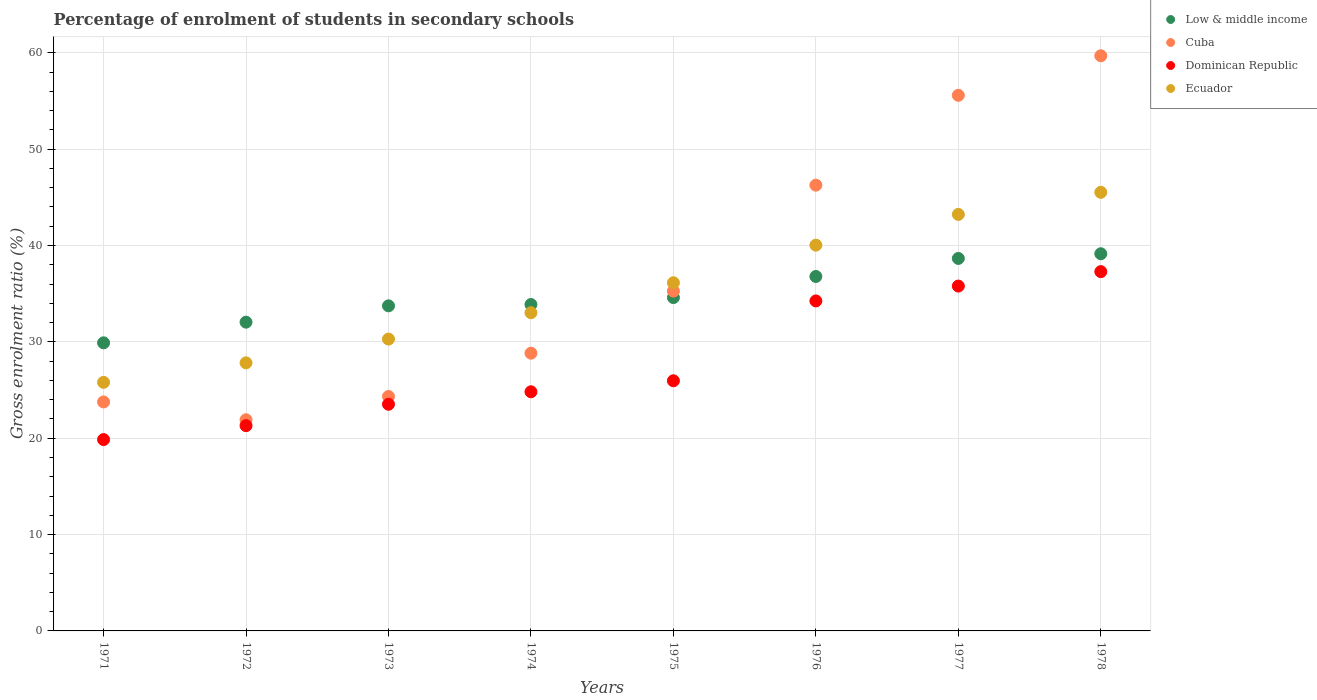How many different coloured dotlines are there?
Give a very brief answer. 4. Is the number of dotlines equal to the number of legend labels?
Ensure brevity in your answer.  Yes. What is the percentage of students enrolled in secondary schools in Cuba in 1977?
Give a very brief answer. 55.59. Across all years, what is the maximum percentage of students enrolled in secondary schools in Low & middle income?
Offer a terse response. 39.15. Across all years, what is the minimum percentage of students enrolled in secondary schools in Low & middle income?
Provide a short and direct response. 29.9. In which year was the percentage of students enrolled in secondary schools in Dominican Republic maximum?
Offer a very short reply. 1978. What is the total percentage of students enrolled in secondary schools in Ecuador in the graph?
Your answer should be compact. 281.85. What is the difference between the percentage of students enrolled in secondary schools in Ecuador in 1972 and that in 1974?
Provide a succinct answer. -5.2. What is the difference between the percentage of students enrolled in secondary schools in Low & middle income in 1971 and the percentage of students enrolled in secondary schools in Cuba in 1976?
Provide a succinct answer. -16.36. What is the average percentage of students enrolled in secondary schools in Dominican Republic per year?
Your answer should be very brief. 27.85. In the year 1974, what is the difference between the percentage of students enrolled in secondary schools in Cuba and percentage of students enrolled in secondary schools in Dominican Republic?
Provide a short and direct response. 4.01. In how many years, is the percentage of students enrolled in secondary schools in Dominican Republic greater than 40 %?
Provide a short and direct response. 0. What is the ratio of the percentage of students enrolled in secondary schools in Cuba in 1973 to that in 1974?
Your response must be concise. 0.84. Is the percentage of students enrolled in secondary schools in Dominican Republic in 1972 less than that in 1976?
Make the answer very short. Yes. What is the difference between the highest and the second highest percentage of students enrolled in secondary schools in Cuba?
Make the answer very short. 4.1. What is the difference between the highest and the lowest percentage of students enrolled in secondary schools in Cuba?
Offer a terse response. 37.78. Is the sum of the percentage of students enrolled in secondary schools in Dominican Republic in 1973 and 1976 greater than the maximum percentage of students enrolled in secondary schools in Ecuador across all years?
Provide a short and direct response. Yes. Does the percentage of students enrolled in secondary schools in Low & middle income monotonically increase over the years?
Offer a very short reply. Yes. Is the percentage of students enrolled in secondary schools in Dominican Republic strictly less than the percentage of students enrolled in secondary schools in Ecuador over the years?
Keep it short and to the point. Yes. How many years are there in the graph?
Your answer should be very brief. 8. Are the values on the major ticks of Y-axis written in scientific E-notation?
Your answer should be very brief. No. Does the graph contain any zero values?
Your response must be concise. No. Where does the legend appear in the graph?
Provide a short and direct response. Top right. How are the legend labels stacked?
Your answer should be compact. Vertical. What is the title of the graph?
Make the answer very short. Percentage of enrolment of students in secondary schools. Does "Lao PDR" appear as one of the legend labels in the graph?
Your answer should be compact. No. What is the label or title of the X-axis?
Offer a very short reply. Years. What is the Gross enrolment ratio (%) in Low & middle income in 1971?
Your answer should be compact. 29.9. What is the Gross enrolment ratio (%) in Cuba in 1971?
Keep it short and to the point. 23.76. What is the Gross enrolment ratio (%) in Dominican Republic in 1971?
Ensure brevity in your answer.  19.86. What is the Gross enrolment ratio (%) of Ecuador in 1971?
Provide a succinct answer. 25.8. What is the Gross enrolment ratio (%) of Low & middle income in 1972?
Provide a succinct answer. 32.04. What is the Gross enrolment ratio (%) of Cuba in 1972?
Your answer should be compact. 21.92. What is the Gross enrolment ratio (%) of Dominican Republic in 1972?
Your answer should be compact. 21.3. What is the Gross enrolment ratio (%) in Ecuador in 1972?
Provide a succinct answer. 27.82. What is the Gross enrolment ratio (%) in Low & middle income in 1973?
Offer a very short reply. 33.74. What is the Gross enrolment ratio (%) in Cuba in 1973?
Keep it short and to the point. 24.33. What is the Gross enrolment ratio (%) of Dominican Republic in 1973?
Keep it short and to the point. 23.52. What is the Gross enrolment ratio (%) of Ecuador in 1973?
Keep it short and to the point. 30.29. What is the Gross enrolment ratio (%) in Low & middle income in 1974?
Your response must be concise. 33.88. What is the Gross enrolment ratio (%) in Cuba in 1974?
Your answer should be very brief. 28.82. What is the Gross enrolment ratio (%) of Dominican Republic in 1974?
Your answer should be very brief. 24.82. What is the Gross enrolment ratio (%) of Ecuador in 1974?
Your answer should be very brief. 33.03. What is the Gross enrolment ratio (%) in Low & middle income in 1975?
Your answer should be very brief. 34.6. What is the Gross enrolment ratio (%) of Cuba in 1975?
Keep it short and to the point. 35.27. What is the Gross enrolment ratio (%) in Dominican Republic in 1975?
Give a very brief answer. 25.96. What is the Gross enrolment ratio (%) in Ecuador in 1975?
Your answer should be compact. 36.13. What is the Gross enrolment ratio (%) of Low & middle income in 1976?
Offer a terse response. 36.79. What is the Gross enrolment ratio (%) of Cuba in 1976?
Your answer should be very brief. 46.26. What is the Gross enrolment ratio (%) of Dominican Republic in 1976?
Make the answer very short. 34.25. What is the Gross enrolment ratio (%) of Ecuador in 1976?
Your response must be concise. 40.04. What is the Gross enrolment ratio (%) of Low & middle income in 1977?
Provide a short and direct response. 38.66. What is the Gross enrolment ratio (%) of Cuba in 1977?
Ensure brevity in your answer.  55.59. What is the Gross enrolment ratio (%) in Dominican Republic in 1977?
Offer a very short reply. 35.79. What is the Gross enrolment ratio (%) of Ecuador in 1977?
Offer a very short reply. 43.23. What is the Gross enrolment ratio (%) in Low & middle income in 1978?
Offer a very short reply. 39.15. What is the Gross enrolment ratio (%) in Cuba in 1978?
Provide a short and direct response. 59.69. What is the Gross enrolment ratio (%) of Dominican Republic in 1978?
Ensure brevity in your answer.  37.29. What is the Gross enrolment ratio (%) of Ecuador in 1978?
Offer a terse response. 45.52. Across all years, what is the maximum Gross enrolment ratio (%) of Low & middle income?
Your response must be concise. 39.15. Across all years, what is the maximum Gross enrolment ratio (%) in Cuba?
Your response must be concise. 59.69. Across all years, what is the maximum Gross enrolment ratio (%) of Dominican Republic?
Your answer should be very brief. 37.29. Across all years, what is the maximum Gross enrolment ratio (%) in Ecuador?
Your answer should be very brief. 45.52. Across all years, what is the minimum Gross enrolment ratio (%) in Low & middle income?
Your answer should be compact. 29.9. Across all years, what is the minimum Gross enrolment ratio (%) in Cuba?
Keep it short and to the point. 21.92. Across all years, what is the minimum Gross enrolment ratio (%) in Dominican Republic?
Offer a very short reply. 19.86. Across all years, what is the minimum Gross enrolment ratio (%) of Ecuador?
Offer a terse response. 25.8. What is the total Gross enrolment ratio (%) of Low & middle income in the graph?
Ensure brevity in your answer.  278.75. What is the total Gross enrolment ratio (%) of Cuba in the graph?
Your answer should be very brief. 295.65. What is the total Gross enrolment ratio (%) in Dominican Republic in the graph?
Your answer should be compact. 222.79. What is the total Gross enrolment ratio (%) of Ecuador in the graph?
Your answer should be very brief. 281.85. What is the difference between the Gross enrolment ratio (%) of Low & middle income in 1971 and that in 1972?
Offer a very short reply. -2.15. What is the difference between the Gross enrolment ratio (%) in Cuba in 1971 and that in 1972?
Keep it short and to the point. 1.85. What is the difference between the Gross enrolment ratio (%) in Dominican Republic in 1971 and that in 1972?
Give a very brief answer. -1.45. What is the difference between the Gross enrolment ratio (%) in Ecuador in 1971 and that in 1972?
Your answer should be compact. -2.02. What is the difference between the Gross enrolment ratio (%) in Low & middle income in 1971 and that in 1973?
Offer a very short reply. -3.84. What is the difference between the Gross enrolment ratio (%) of Cuba in 1971 and that in 1973?
Keep it short and to the point. -0.57. What is the difference between the Gross enrolment ratio (%) of Dominican Republic in 1971 and that in 1973?
Provide a short and direct response. -3.67. What is the difference between the Gross enrolment ratio (%) in Ecuador in 1971 and that in 1973?
Offer a terse response. -4.49. What is the difference between the Gross enrolment ratio (%) of Low & middle income in 1971 and that in 1974?
Make the answer very short. -3.98. What is the difference between the Gross enrolment ratio (%) of Cuba in 1971 and that in 1974?
Your answer should be compact. -5.06. What is the difference between the Gross enrolment ratio (%) of Dominican Republic in 1971 and that in 1974?
Offer a very short reply. -4.96. What is the difference between the Gross enrolment ratio (%) of Ecuador in 1971 and that in 1974?
Provide a succinct answer. -7.23. What is the difference between the Gross enrolment ratio (%) in Low & middle income in 1971 and that in 1975?
Keep it short and to the point. -4.7. What is the difference between the Gross enrolment ratio (%) of Cuba in 1971 and that in 1975?
Your answer should be compact. -11.5. What is the difference between the Gross enrolment ratio (%) of Dominican Republic in 1971 and that in 1975?
Keep it short and to the point. -6.1. What is the difference between the Gross enrolment ratio (%) in Ecuador in 1971 and that in 1975?
Your answer should be compact. -10.33. What is the difference between the Gross enrolment ratio (%) of Low & middle income in 1971 and that in 1976?
Make the answer very short. -6.89. What is the difference between the Gross enrolment ratio (%) of Cuba in 1971 and that in 1976?
Your answer should be very brief. -22.5. What is the difference between the Gross enrolment ratio (%) in Dominican Republic in 1971 and that in 1976?
Give a very brief answer. -14.39. What is the difference between the Gross enrolment ratio (%) of Ecuador in 1971 and that in 1976?
Keep it short and to the point. -14.24. What is the difference between the Gross enrolment ratio (%) of Low & middle income in 1971 and that in 1977?
Your answer should be very brief. -8.76. What is the difference between the Gross enrolment ratio (%) in Cuba in 1971 and that in 1977?
Ensure brevity in your answer.  -31.83. What is the difference between the Gross enrolment ratio (%) of Dominican Republic in 1971 and that in 1977?
Provide a short and direct response. -15.93. What is the difference between the Gross enrolment ratio (%) of Ecuador in 1971 and that in 1977?
Give a very brief answer. -17.43. What is the difference between the Gross enrolment ratio (%) in Low & middle income in 1971 and that in 1978?
Make the answer very short. -9.25. What is the difference between the Gross enrolment ratio (%) in Cuba in 1971 and that in 1978?
Your answer should be very brief. -35.93. What is the difference between the Gross enrolment ratio (%) in Dominican Republic in 1971 and that in 1978?
Keep it short and to the point. -17.43. What is the difference between the Gross enrolment ratio (%) in Ecuador in 1971 and that in 1978?
Make the answer very short. -19.72. What is the difference between the Gross enrolment ratio (%) in Low & middle income in 1972 and that in 1973?
Offer a very short reply. -1.69. What is the difference between the Gross enrolment ratio (%) of Cuba in 1972 and that in 1973?
Offer a very short reply. -2.42. What is the difference between the Gross enrolment ratio (%) of Dominican Republic in 1972 and that in 1973?
Offer a terse response. -2.22. What is the difference between the Gross enrolment ratio (%) in Ecuador in 1972 and that in 1973?
Give a very brief answer. -2.47. What is the difference between the Gross enrolment ratio (%) in Low & middle income in 1972 and that in 1974?
Give a very brief answer. -1.83. What is the difference between the Gross enrolment ratio (%) of Cuba in 1972 and that in 1974?
Your response must be concise. -6.91. What is the difference between the Gross enrolment ratio (%) in Dominican Republic in 1972 and that in 1974?
Ensure brevity in your answer.  -3.51. What is the difference between the Gross enrolment ratio (%) of Ecuador in 1972 and that in 1974?
Give a very brief answer. -5.2. What is the difference between the Gross enrolment ratio (%) in Low & middle income in 1972 and that in 1975?
Ensure brevity in your answer.  -2.55. What is the difference between the Gross enrolment ratio (%) in Cuba in 1972 and that in 1975?
Your answer should be compact. -13.35. What is the difference between the Gross enrolment ratio (%) of Dominican Republic in 1972 and that in 1975?
Offer a very short reply. -4.66. What is the difference between the Gross enrolment ratio (%) in Ecuador in 1972 and that in 1975?
Your response must be concise. -8.31. What is the difference between the Gross enrolment ratio (%) of Low & middle income in 1972 and that in 1976?
Your answer should be compact. -4.74. What is the difference between the Gross enrolment ratio (%) of Cuba in 1972 and that in 1976?
Your answer should be very brief. -24.35. What is the difference between the Gross enrolment ratio (%) in Dominican Republic in 1972 and that in 1976?
Provide a succinct answer. -12.94. What is the difference between the Gross enrolment ratio (%) of Ecuador in 1972 and that in 1976?
Offer a very short reply. -12.21. What is the difference between the Gross enrolment ratio (%) of Low & middle income in 1972 and that in 1977?
Offer a very short reply. -6.61. What is the difference between the Gross enrolment ratio (%) in Cuba in 1972 and that in 1977?
Your answer should be compact. -33.67. What is the difference between the Gross enrolment ratio (%) of Dominican Republic in 1972 and that in 1977?
Keep it short and to the point. -14.49. What is the difference between the Gross enrolment ratio (%) of Ecuador in 1972 and that in 1977?
Give a very brief answer. -15.41. What is the difference between the Gross enrolment ratio (%) in Low & middle income in 1972 and that in 1978?
Your answer should be very brief. -7.1. What is the difference between the Gross enrolment ratio (%) of Cuba in 1972 and that in 1978?
Ensure brevity in your answer.  -37.78. What is the difference between the Gross enrolment ratio (%) of Dominican Republic in 1972 and that in 1978?
Provide a short and direct response. -15.98. What is the difference between the Gross enrolment ratio (%) of Ecuador in 1972 and that in 1978?
Offer a very short reply. -17.7. What is the difference between the Gross enrolment ratio (%) in Low & middle income in 1973 and that in 1974?
Offer a terse response. -0.14. What is the difference between the Gross enrolment ratio (%) in Cuba in 1973 and that in 1974?
Offer a very short reply. -4.49. What is the difference between the Gross enrolment ratio (%) of Dominican Republic in 1973 and that in 1974?
Make the answer very short. -1.3. What is the difference between the Gross enrolment ratio (%) of Ecuador in 1973 and that in 1974?
Ensure brevity in your answer.  -2.74. What is the difference between the Gross enrolment ratio (%) in Low & middle income in 1973 and that in 1975?
Make the answer very short. -0.86. What is the difference between the Gross enrolment ratio (%) of Cuba in 1973 and that in 1975?
Your answer should be very brief. -10.94. What is the difference between the Gross enrolment ratio (%) of Dominican Republic in 1973 and that in 1975?
Provide a succinct answer. -2.44. What is the difference between the Gross enrolment ratio (%) in Ecuador in 1973 and that in 1975?
Your answer should be compact. -5.84. What is the difference between the Gross enrolment ratio (%) in Low & middle income in 1973 and that in 1976?
Your answer should be compact. -3.05. What is the difference between the Gross enrolment ratio (%) of Cuba in 1973 and that in 1976?
Ensure brevity in your answer.  -21.93. What is the difference between the Gross enrolment ratio (%) in Dominican Republic in 1973 and that in 1976?
Give a very brief answer. -10.73. What is the difference between the Gross enrolment ratio (%) of Ecuador in 1973 and that in 1976?
Give a very brief answer. -9.75. What is the difference between the Gross enrolment ratio (%) of Low & middle income in 1973 and that in 1977?
Keep it short and to the point. -4.92. What is the difference between the Gross enrolment ratio (%) in Cuba in 1973 and that in 1977?
Give a very brief answer. -31.26. What is the difference between the Gross enrolment ratio (%) of Dominican Republic in 1973 and that in 1977?
Offer a terse response. -12.27. What is the difference between the Gross enrolment ratio (%) in Ecuador in 1973 and that in 1977?
Offer a very short reply. -12.94. What is the difference between the Gross enrolment ratio (%) of Low & middle income in 1973 and that in 1978?
Offer a very short reply. -5.41. What is the difference between the Gross enrolment ratio (%) in Cuba in 1973 and that in 1978?
Your answer should be very brief. -35.36. What is the difference between the Gross enrolment ratio (%) in Dominican Republic in 1973 and that in 1978?
Keep it short and to the point. -13.77. What is the difference between the Gross enrolment ratio (%) of Ecuador in 1973 and that in 1978?
Ensure brevity in your answer.  -15.23. What is the difference between the Gross enrolment ratio (%) in Low & middle income in 1974 and that in 1975?
Offer a terse response. -0.72. What is the difference between the Gross enrolment ratio (%) of Cuba in 1974 and that in 1975?
Provide a succinct answer. -6.44. What is the difference between the Gross enrolment ratio (%) of Dominican Republic in 1974 and that in 1975?
Your answer should be compact. -1.14. What is the difference between the Gross enrolment ratio (%) of Ecuador in 1974 and that in 1975?
Keep it short and to the point. -3.11. What is the difference between the Gross enrolment ratio (%) in Low & middle income in 1974 and that in 1976?
Give a very brief answer. -2.91. What is the difference between the Gross enrolment ratio (%) of Cuba in 1974 and that in 1976?
Your answer should be very brief. -17.44. What is the difference between the Gross enrolment ratio (%) of Dominican Republic in 1974 and that in 1976?
Your response must be concise. -9.43. What is the difference between the Gross enrolment ratio (%) of Ecuador in 1974 and that in 1976?
Your response must be concise. -7.01. What is the difference between the Gross enrolment ratio (%) in Low & middle income in 1974 and that in 1977?
Provide a succinct answer. -4.78. What is the difference between the Gross enrolment ratio (%) in Cuba in 1974 and that in 1977?
Your response must be concise. -26.76. What is the difference between the Gross enrolment ratio (%) in Dominican Republic in 1974 and that in 1977?
Keep it short and to the point. -10.97. What is the difference between the Gross enrolment ratio (%) of Ecuador in 1974 and that in 1977?
Make the answer very short. -10.2. What is the difference between the Gross enrolment ratio (%) of Low & middle income in 1974 and that in 1978?
Offer a very short reply. -5.27. What is the difference between the Gross enrolment ratio (%) of Cuba in 1974 and that in 1978?
Offer a terse response. -30.87. What is the difference between the Gross enrolment ratio (%) in Dominican Republic in 1974 and that in 1978?
Offer a very short reply. -12.47. What is the difference between the Gross enrolment ratio (%) of Ecuador in 1974 and that in 1978?
Provide a succinct answer. -12.49. What is the difference between the Gross enrolment ratio (%) in Low & middle income in 1975 and that in 1976?
Give a very brief answer. -2.19. What is the difference between the Gross enrolment ratio (%) of Cuba in 1975 and that in 1976?
Provide a succinct answer. -11. What is the difference between the Gross enrolment ratio (%) in Dominican Republic in 1975 and that in 1976?
Your answer should be compact. -8.29. What is the difference between the Gross enrolment ratio (%) in Ecuador in 1975 and that in 1976?
Your response must be concise. -3.9. What is the difference between the Gross enrolment ratio (%) of Low & middle income in 1975 and that in 1977?
Your answer should be very brief. -4.06. What is the difference between the Gross enrolment ratio (%) in Cuba in 1975 and that in 1977?
Your response must be concise. -20.32. What is the difference between the Gross enrolment ratio (%) of Dominican Republic in 1975 and that in 1977?
Make the answer very short. -9.83. What is the difference between the Gross enrolment ratio (%) of Ecuador in 1975 and that in 1977?
Ensure brevity in your answer.  -7.09. What is the difference between the Gross enrolment ratio (%) in Low & middle income in 1975 and that in 1978?
Give a very brief answer. -4.55. What is the difference between the Gross enrolment ratio (%) of Cuba in 1975 and that in 1978?
Offer a very short reply. -24.43. What is the difference between the Gross enrolment ratio (%) in Dominican Republic in 1975 and that in 1978?
Provide a succinct answer. -11.33. What is the difference between the Gross enrolment ratio (%) in Ecuador in 1975 and that in 1978?
Offer a very short reply. -9.39. What is the difference between the Gross enrolment ratio (%) in Low & middle income in 1976 and that in 1977?
Ensure brevity in your answer.  -1.87. What is the difference between the Gross enrolment ratio (%) in Cuba in 1976 and that in 1977?
Make the answer very short. -9.32. What is the difference between the Gross enrolment ratio (%) in Dominican Republic in 1976 and that in 1977?
Your answer should be very brief. -1.54. What is the difference between the Gross enrolment ratio (%) in Ecuador in 1976 and that in 1977?
Ensure brevity in your answer.  -3.19. What is the difference between the Gross enrolment ratio (%) of Low & middle income in 1976 and that in 1978?
Ensure brevity in your answer.  -2.36. What is the difference between the Gross enrolment ratio (%) in Cuba in 1976 and that in 1978?
Give a very brief answer. -13.43. What is the difference between the Gross enrolment ratio (%) of Dominican Republic in 1976 and that in 1978?
Keep it short and to the point. -3.04. What is the difference between the Gross enrolment ratio (%) in Ecuador in 1976 and that in 1978?
Offer a terse response. -5.48. What is the difference between the Gross enrolment ratio (%) in Low & middle income in 1977 and that in 1978?
Provide a short and direct response. -0.49. What is the difference between the Gross enrolment ratio (%) in Cuba in 1977 and that in 1978?
Give a very brief answer. -4.1. What is the difference between the Gross enrolment ratio (%) in Dominican Republic in 1977 and that in 1978?
Ensure brevity in your answer.  -1.5. What is the difference between the Gross enrolment ratio (%) in Ecuador in 1977 and that in 1978?
Give a very brief answer. -2.29. What is the difference between the Gross enrolment ratio (%) of Low & middle income in 1971 and the Gross enrolment ratio (%) of Cuba in 1972?
Provide a succinct answer. 7.98. What is the difference between the Gross enrolment ratio (%) of Low & middle income in 1971 and the Gross enrolment ratio (%) of Dominican Republic in 1972?
Your answer should be compact. 8.59. What is the difference between the Gross enrolment ratio (%) of Low & middle income in 1971 and the Gross enrolment ratio (%) of Ecuador in 1972?
Give a very brief answer. 2.08. What is the difference between the Gross enrolment ratio (%) of Cuba in 1971 and the Gross enrolment ratio (%) of Dominican Republic in 1972?
Keep it short and to the point. 2.46. What is the difference between the Gross enrolment ratio (%) in Cuba in 1971 and the Gross enrolment ratio (%) in Ecuador in 1972?
Your answer should be compact. -4.06. What is the difference between the Gross enrolment ratio (%) of Dominican Republic in 1971 and the Gross enrolment ratio (%) of Ecuador in 1972?
Provide a succinct answer. -7.96. What is the difference between the Gross enrolment ratio (%) in Low & middle income in 1971 and the Gross enrolment ratio (%) in Cuba in 1973?
Provide a succinct answer. 5.57. What is the difference between the Gross enrolment ratio (%) in Low & middle income in 1971 and the Gross enrolment ratio (%) in Dominican Republic in 1973?
Make the answer very short. 6.38. What is the difference between the Gross enrolment ratio (%) of Low & middle income in 1971 and the Gross enrolment ratio (%) of Ecuador in 1973?
Offer a very short reply. -0.39. What is the difference between the Gross enrolment ratio (%) in Cuba in 1971 and the Gross enrolment ratio (%) in Dominican Republic in 1973?
Your answer should be very brief. 0.24. What is the difference between the Gross enrolment ratio (%) in Cuba in 1971 and the Gross enrolment ratio (%) in Ecuador in 1973?
Offer a very short reply. -6.53. What is the difference between the Gross enrolment ratio (%) in Dominican Republic in 1971 and the Gross enrolment ratio (%) in Ecuador in 1973?
Your answer should be very brief. -10.43. What is the difference between the Gross enrolment ratio (%) in Low & middle income in 1971 and the Gross enrolment ratio (%) in Cuba in 1974?
Your response must be concise. 1.07. What is the difference between the Gross enrolment ratio (%) in Low & middle income in 1971 and the Gross enrolment ratio (%) in Dominican Republic in 1974?
Keep it short and to the point. 5.08. What is the difference between the Gross enrolment ratio (%) in Low & middle income in 1971 and the Gross enrolment ratio (%) in Ecuador in 1974?
Your answer should be very brief. -3.13. What is the difference between the Gross enrolment ratio (%) in Cuba in 1971 and the Gross enrolment ratio (%) in Dominican Republic in 1974?
Offer a very short reply. -1.06. What is the difference between the Gross enrolment ratio (%) in Cuba in 1971 and the Gross enrolment ratio (%) in Ecuador in 1974?
Provide a succinct answer. -9.26. What is the difference between the Gross enrolment ratio (%) in Dominican Republic in 1971 and the Gross enrolment ratio (%) in Ecuador in 1974?
Provide a short and direct response. -13.17. What is the difference between the Gross enrolment ratio (%) of Low & middle income in 1971 and the Gross enrolment ratio (%) of Cuba in 1975?
Make the answer very short. -5.37. What is the difference between the Gross enrolment ratio (%) of Low & middle income in 1971 and the Gross enrolment ratio (%) of Dominican Republic in 1975?
Keep it short and to the point. 3.94. What is the difference between the Gross enrolment ratio (%) in Low & middle income in 1971 and the Gross enrolment ratio (%) in Ecuador in 1975?
Offer a very short reply. -6.23. What is the difference between the Gross enrolment ratio (%) of Cuba in 1971 and the Gross enrolment ratio (%) of Dominican Republic in 1975?
Keep it short and to the point. -2.2. What is the difference between the Gross enrolment ratio (%) of Cuba in 1971 and the Gross enrolment ratio (%) of Ecuador in 1975?
Keep it short and to the point. -12.37. What is the difference between the Gross enrolment ratio (%) in Dominican Republic in 1971 and the Gross enrolment ratio (%) in Ecuador in 1975?
Offer a terse response. -16.28. What is the difference between the Gross enrolment ratio (%) of Low & middle income in 1971 and the Gross enrolment ratio (%) of Cuba in 1976?
Your answer should be compact. -16.36. What is the difference between the Gross enrolment ratio (%) in Low & middle income in 1971 and the Gross enrolment ratio (%) in Dominican Republic in 1976?
Ensure brevity in your answer.  -4.35. What is the difference between the Gross enrolment ratio (%) of Low & middle income in 1971 and the Gross enrolment ratio (%) of Ecuador in 1976?
Keep it short and to the point. -10.14. What is the difference between the Gross enrolment ratio (%) in Cuba in 1971 and the Gross enrolment ratio (%) in Dominican Republic in 1976?
Keep it short and to the point. -10.48. What is the difference between the Gross enrolment ratio (%) of Cuba in 1971 and the Gross enrolment ratio (%) of Ecuador in 1976?
Your answer should be compact. -16.27. What is the difference between the Gross enrolment ratio (%) of Dominican Republic in 1971 and the Gross enrolment ratio (%) of Ecuador in 1976?
Your answer should be compact. -20.18. What is the difference between the Gross enrolment ratio (%) in Low & middle income in 1971 and the Gross enrolment ratio (%) in Cuba in 1977?
Offer a very short reply. -25.69. What is the difference between the Gross enrolment ratio (%) of Low & middle income in 1971 and the Gross enrolment ratio (%) of Dominican Republic in 1977?
Keep it short and to the point. -5.89. What is the difference between the Gross enrolment ratio (%) of Low & middle income in 1971 and the Gross enrolment ratio (%) of Ecuador in 1977?
Offer a terse response. -13.33. What is the difference between the Gross enrolment ratio (%) in Cuba in 1971 and the Gross enrolment ratio (%) in Dominican Republic in 1977?
Offer a very short reply. -12.03. What is the difference between the Gross enrolment ratio (%) in Cuba in 1971 and the Gross enrolment ratio (%) in Ecuador in 1977?
Your answer should be very brief. -19.46. What is the difference between the Gross enrolment ratio (%) of Dominican Republic in 1971 and the Gross enrolment ratio (%) of Ecuador in 1977?
Offer a very short reply. -23.37. What is the difference between the Gross enrolment ratio (%) of Low & middle income in 1971 and the Gross enrolment ratio (%) of Cuba in 1978?
Give a very brief answer. -29.79. What is the difference between the Gross enrolment ratio (%) in Low & middle income in 1971 and the Gross enrolment ratio (%) in Dominican Republic in 1978?
Keep it short and to the point. -7.39. What is the difference between the Gross enrolment ratio (%) in Low & middle income in 1971 and the Gross enrolment ratio (%) in Ecuador in 1978?
Your answer should be compact. -15.62. What is the difference between the Gross enrolment ratio (%) in Cuba in 1971 and the Gross enrolment ratio (%) in Dominican Republic in 1978?
Provide a short and direct response. -13.52. What is the difference between the Gross enrolment ratio (%) in Cuba in 1971 and the Gross enrolment ratio (%) in Ecuador in 1978?
Make the answer very short. -21.76. What is the difference between the Gross enrolment ratio (%) of Dominican Republic in 1971 and the Gross enrolment ratio (%) of Ecuador in 1978?
Provide a short and direct response. -25.66. What is the difference between the Gross enrolment ratio (%) of Low & middle income in 1972 and the Gross enrolment ratio (%) of Cuba in 1973?
Provide a short and direct response. 7.71. What is the difference between the Gross enrolment ratio (%) of Low & middle income in 1972 and the Gross enrolment ratio (%) of Dominican Republic in 1973?
Your response must be concise. 8.52. What is the difference between the Gross enrolment ratio (%) in Low & middle income in 1972 and the Gross enrolment ratio (%) in Ecuador in 1973?
Keep it short and to the point. 1.76. What is the difference between the Gross enrolment ratio (%) in Cuba in 1972 and the Gross enrolment ratio (%) in Dominican Republic in 1973?
Make the answer very short. -1.61. What is the difference between the Gross enrolment ratio (%) of Cuba in 1972 and the Gross enrolment ratio (%) of Ecuador in 1973?
Offer a terse response. -8.37. What is the difference between the Gross enrolment ratio (%) of Dominican Republic in 1972 and the Gross enrolment ratio (%) of Ecuador in 1973?
Give a very brief answer. -8.98. What is the difference between the Gross enrolment ratio (%) in Low & middle income in 1972 and the Gross enrolment ratio (%) in Cuba in 1974?
Make the answer very short. 3.22. What is the difference between the Gross enrolment ratio (%) in Low & middle income in 1972 and the Gross enrolment ratio (%) in Dominican Republic in 1974?
Your response must be concise. 7.23. What is the difference between the Gross enrolment ratio (%) in Low & middle income in 1972 and the Gross enrolment ratio (%) in Ecuador in 1974?
Your response must be concise. -0.98. What is the difference between the Gross enrolment ratio (%) of Cuba in 1972 and the Gross enrolment ratio (%) of Dominican Republic in 1974?
Provide a short and direct response. -2.9. What is the difference between the Gross enrolment ratio (%) of Cuba in 1972 and the Gross enrolment ratio (%) of Ecuador in 1974?
Your response must be concise. -11.11. What is the difference between the Gross enrolment ratio (%) of Dominican Republic in 1972 and the Gross enrolment ratio (%) of Ecuador in 1974?
Ensure brevity in your answer.  -11.72. What is the difference between the Gross enrolment ratio (%) in Low & middle income in 1972 and the Gross enrolment ratio (%) in Cuba in 1975?
Your answer should be very brief. -3.22. What is the difference between the Gross enrolment ratio (%) in Low & middle income in 1972 and the Gross enrolment ratio (%) in Dominican Republic in 1975?
Provide a short and direct response. 6.08. What is the difference between the Gross enrolment ratio (%) in Low & middle income in 1972 and the Gross enrolment ratio (%) in Ecuador in 1975?
Ensure brevity in your answer.  -4.09. What is the difference between the Gross enrolment ratio (%) in Cuba in 1972 and the Gross enrolment ratio (%) in Dominican Republic in 1975?
Your response must be concise. -4.05. What is the difference between the Gross enrolment ratio (%) of Cuba in 1972 and the Gross enrolment ratio (%) of Ecuador in 1975?
Your answer should be compact. -14.22. What is the difference between the Gross enrolment ratio (%) of Dominican Republic in 1972 and the Gross enrolment ratio (%) of Ecuador in 1975?
Provide a succinct answer. -14.83. What is the difference between the Gross enrolment ratio (%) in Low & middle income in 1972 and the Gross enrolment ratio (%) in Cuba in 1976?
Offer a terse response. -14.22. What is the difference between the Gross enrolment ratio (%) of Low & middle income in 1972 and the Gross enrolment ratio (%) of Dominican Republic in 1976?
Ensure brevity in your answer.  -2.2. What is the difference between the Gross enrolment ratio (%) in Low & middle income in 1972 and the Gross enrolment ratio (%) in Ecuador in 1976?
Your response must be concise. -7.99. What is the difference between the Gross enrolment ratio (%) of Cuba in 1972 and the Gross enrolment ratio (%) of Dominican Republic in 1976?
Provide a short and direct response. -12.33. What is the difference between the Gross enrolment ratio (%) of Cuba in 1972 and the Gross enrolment ratio (%) of Ecuador in 1976?
Provide a succinct answer. -18.12. What is the difference between the Gross enrolment ratio (%) of Dominican Republic in 1972 and the Gross enrolment ratio (%) of Ecuador in 1976?
Your response must be concise. -18.73. What is the difference between the Gross enrolment ratio (%) in Low & middle income in 1972 and the Gross enrolment ratio (%) in Cuba in 1977?
Make the answer very short. -23.54. What is the difference between the Gross enrolment ratio (%) of Low & middle income in 1972 and the Gross enrolment ratio (%) of Dominican Republic in 1977?
Your response must be concise. -3.75. What is the difference between the Gross enrolment ratio (%) of Low & middle income in 1972 and the Gross enrolment ratio (%) of Ecuador in 1977?
Make the answer very short. -11.18. What is the difference between the Gross enrolment ratio (%) in Cuba in 1972 and the Gross enrolment ratio (%) in Dominican Republic in 1977?
Your answer should be compact. -13.87. What is the difference between the Gross enrolment ratio (%) of Cuba in 1972 and the Gross enrolment ratio (%) of Ecuador in 1977?
Your answer should be very brief. -21.31. What is the difference between the Gross enrolment ratio (%) of Dominican Republic in 1972 and the Gross enrolment ratio (%) of Ecuador in 1977?
Keep it short and to the point. -21.92. What is the difference between the Gross enrolment ratio (%) of Low & middle income in 1972 and the Gross enrolment ratio (%) of Cuba in 1978?
Offer a terse response. -27.65. What is the difference between the Gross enrolment ratio (%) in Low & middle income in 1972 and the Gross enrolment ratio (%) in Dominican Republic in 1978?
Your response must be concise. -5.24. What is the difference between the Gross enrolment ratio (%) in Low & middle income in 1972 and the Gross enrolment ratio (%) in Ecuador in 1978?
Provide a succinct answer. -13.47. What is the difference between the Gross enrolment ratio (%) in Cuba in 1972 and the Gross enrolment ratio (%) in Dominican Republic in 1978?
Make the answer very short. -15.37. What is the difference between the Gross enrolment ratio (%) of Cuba in 1972 and the Gross enrolment ratio (%) of Ecuador in 1978?
Ensure brevity in your answer.  -23.6. What is the difference between the Gross enrolment ratio (%) in Dominican Republic in 1972 and the Gross enrolment ratio (%) in Ecuador in 1978?
Provide a short and direct response. -24.22. What is the difference between the Gross enrolment ratio (%) of Low & middle income in 1973 and the Gross enrolment ratio (%) of Cuba in 1974?
Your answer should be very brief. 4.91. What is the difference between the Gross enrolment ratio (%) in Low & middle income in 1973 and the Gross enrolment ratio (%) in Dominican Republic in 1974?
Make the answer very short. 8.92. What is the difference between the Gross enrolment ratio (%) of Low & middle income in 1973 and the Gross enrolment ratio (%) of Ecuador in 1974?
Offer a terse response. 0.71. What is the difference between the Gross enrolment ratio (%) of Cuba in 1973 and the Gross enrolment ratio (%) of Dominican Republic in 1974?
Your answer should be very brief. -0.49. What is the difference between the Gross enrolment ratio (%) of Cuba in 1973 and the Gross enrolment ratio (%) of Ecuador in 1974?
Your answer should be very brief. -8.69. What is the difference between the Gross enrolment ratio (%) in Dominican Republic in 1973 and the Gross enrolment ratio (%) in Ecuador in 1974?
Offer a very short reply. -9.5. What is the difference between the Gross enrolment ratio (%) of Low & middle income in 1973 and the Gross enrolment ratio (%) of Cuba in 1975?
Make the answer very short. -1.53. What is the difference between the Gross enrolment ratio (%) of Low & middle income in 1973 and the Gross enrolment ratio (%) of Dominican Republic in 1975?
Give a very brief answer. 7.78. What is the difference between the Gross enrolment ratio (%) of Low & middle income in 1973 and the Gross enrolment ratio (%) of Ecuador in 1975?
Keep it short and to the point. -2.39. What is the difference between the Gross enrolment ratio (%) in Cuba in 1973 and the Gross enrolment ratio (%) in Dominican Republic in 1975?
Your answer should be very brief. -1.63. What is the difference between the Gross enrolment ratio (%) of Cuba in 1973 and the Gross enrolment ratio (%) of Ecuador in 1975?
Provide a succinct answer. -11.8. What is the difference between the Gross enrolment ratio (%) of Dominican Republic in 1973 and the Gross enrolment ratio (%) of Ecuador in 1975?
Provide a succinct answer. -12.61. What is the difference between the Gross enrolment ratio (%) in Low & middle income in 1973 and the Gross enrolment ratio (%) in Cuba in 1976?
Make the answer very short. -12.53. What is the difference between the Gross enrolment ratio (%) of Low & middle income in 1973 and the Gross enrolment ratio (%) of Dominican Republic in 1976?
Your response must be concise. -0.51. What is the difference between the Gross enrolment ratio (%) in Low & middle income in 1973 and the Gross enrolment ratio (%) in Ecuador in 1976?
Ensure brevity in your answer.  -6.3. What is the difference between the Gross enrolment ratio (%) of Cuba in 1973 and the Gross enrolment ratio (%) of Dominican Republic in 1976?
Give a very brief answer. -9.92. What is the difference between the Gross enrolment ratio (%) of Cuba in 1973 and the Gross enrolment ratio (%) of Ecuador in 1976?
Your response must be concise. -15.71. What is the difference between the Gross enrolment ratio (%) in Dominican Republic in 1973 and the Gross enrolment ratio (%) in Ecuador in 1976?
Your answer should be compact. -16.51. What is the difference between the Gross enrolment ratio (%) of Low & middle income in 1973 and the Gross enrolment ratio (%) of Cuba in 1977?
Your response must be concise. -21.85. What is the difference between the Gross enrolment ratio (%) of Low & middle income in 1973 and the Gross enrolment ratio (%) of Dominican Republic in 1977?
Your response must be concise. -2.05. What is the difference between the Gross enrolment ratio (%) in Low & middle income in 1973 and the Gross enrolment ratio (%) in Ecuador in 1977?
Give a very brief answer. -9.49. What is the difference between the Gross enrolment ratio (%) of Cuba in 1973 and the Gross enrolment ratio (%) of Dominican Republic in 1977?
Give a very brief answer. -11.46. What is the difference between the Gross enrolment ratio (%) of Cuba in 1973 and the Gross enrolment ratio (%) of Ecuador in 1977?
Keep it short and to the point. -18.9. What is the difference between the Gross enrolment ratio (%) of Dominican Republic in 1973 and the Gross enrolment ratio (%) of Ecuador in 1977?
Keep it short and to the point. -19.7. What is the difference between the Gross enrolment ratio (%) in Low & middle income in 1973 and the Gross enrolment ratio (%) in Cuba in 1978?
Make the answer very short. -25.95. What is the difference between the Gross enrolment ratio (%) of Low & middle income in 1973 and the Gross enrolment ratio (%) of Dominican Republic in 1978?
Give a very brief answer. -3.55. What is the difference between the Gross enrolment ratio (%) in Low & middle income in 1973 and the Gross enrolment ratio (%) in Ecuador in 1978?
Your answer should be very brief. -11.78. What is the difference between the Gross enrolment ratio (%) in Cuba in 1973 and the Gross enrolment ratio (%) in Dominican Republic in 1978?
Ensure brevity in your answer.  -12.96. What is the difference between the Gross enrolment ratio (%) in Cuba in 1973 and the Gross enrolment ratio (%) in Ecuador in 1978?
Your answer should be very brief. -21.19. What is the difference between the Gross enrolment ratio (%) in Dominican Republic in 1973 and the Gross enrolment ratio (%) in Ecuador in 1978?
Offer a terse response. -22. What is the difference between the Gross enrolment ratio (%) in Low & middle income in 1974 and the Gross enrolment ratio (%) in Cuba in 1975?
Offer a very short reply. -1.39. What is the difference between the Gross enrolment ratio (%) in Low & middle income in 1974 and the Gross enrolment ratio (%) in Dominican Republic in 1975?
Provide a succinct answer. 7.91. What is the difference between the Gross enrolment ratio (%) of Low & middle income in 1974 and the Gross enrolment ratio (%) of Ecuador in 1975?
Keep it short and to the point. -2.26. What is the difference between the Gross enrolment ratio (%) of Cuba in 1974 and the Gross enrolment ratio (%) of Dominican Republic in 1975?
Make the answer very short. 2.86. What is the difference between the Gross enrolment ratio (%) of Cuba in 1974 and the Gross enrolment ratio (%) of Ecuador in 1975?
Make the answer very short. -7.31. What is the difference between the Gross enrolment ratio (%) of Dominican Republic in 1974 and the Gross enrolment ratio (%) of Ecuador in 1975?
Keep it short and to the point. -11.31. What is the difference between the Gross enrolment ratio (%) of Low & middle income in 1974 and the Gross enrolment ratio (%) of Cuba in 1976?
Your answer should be compact. -12.39. What is the difference between the Gross enrolment ratio (%) in Low & middle income in 1974 and the Gross enrolment ratio (%) in Dominican Republic in 1976?
Your answer should be compact. -0.37. What is the difference between the Gross enrolment ratio (%) in Low & middle income in 1974 and the Gross enrolment ratio (%) in Ecuador in 1976?
Provide a short and direct response. -6.16. What is the difference between the Gross enrolment ratio (%) in Cuba in 1974 and the Gross enrolment ratio (%) in Dominican Republic in 1976?
Offer a terse response. -5.42. What is the difference between the Gross enrolment ratio (%) of Cuba in 1974 and the Gross enrolment ratio (%) of Ecuador in 1976?
Give a very brief answer. -11.21. What is the difference between the Gross enrolment ratio (%) of Dominican Republic in 1974 and the Gross enrolment ratio (%) of Ecuador in 1976?
Your response must be concise. -15.22. What is the difference between the Gross enrolment ratio (%) of Low & middle income in 1974 and the Gross enrolment ratio (%) of Cuba in 1977?
Your answer should be compact. -21.71. What is the difference between the Gross enrolment ratio (%) in Low & middle income in 1974 and the Gross enrolment ratio (%) in Dominican Republic in 1977?
Keep it short and to the point. -1.91. What is the difference between the Gross enrolment ratio (%) of Low & middle income in 1974 and the Gross enrolment ratio (%) of Ecuador in 1977?
Offer a very short reply. -9.35. What is the difference between the Gross enrolment ratio (%) in Cuba in 1974 and the Gross enrolment ratio (%) in Dominican Republic in 1977?
Provide a succinct answer. -6.97. What is the difference between the Gross enrolment ratio (%) in Cuba in 1974 and the Gross enrolment ratio (%) in Ecuador in 1977?
Your answer should be very brief. -14.4. What is the difference between the Gross enrolment ratio (%) of Dominican Republic in 1974 and the Gross enrolment ratio (%) of Ecuador in 1977?
Ensure brevity in your answer.  -18.41. What is the difference between the Gross enrolment ratio (%) of Low & middle income in 1974 and the Gross enrolment ratio (%) of Cuba in 1978?
Provide a short and direct response. -25.82. What is the difference between the Gross enrolment ratio (%) in Low & middle income in 1974 and the Gross enrolment ratio (%) in Dominican Republic in 1978?
Your answer should be compact. -3.41. What is the difference between the Gross enrolment ratio (%) in Low & middle income in 1974 and the Gross enrolment ratio (%) in Ecuador in 1978?
Ensure brevity in your answer.  -11.64. What is the difference between the Gross enrolment ratio (%) in Cuba in 1974 and the Gross enrolment ratio (%) in Dominican Republic in 1978?
Ensure brevity in your answer.  -8.46. What is the difference between the Gross enrolment ratio (%) of Cuba in 1974 and the Gross enrolment ratio (%) of Ecuador in 1978?
Ensure brevity in your answer.  -16.7. What is the difference between the Gross enrolment ratio (%) of Dominican Republic in 1974 and the Gross enrolment ratio (%) of Ecuador in 1978?
Provide a short and direct response. -20.7. What is the difference between the Gross enrolment ratio (%) of Low & middle income in 1975 and the Gross enrolment ratio (%) of Cuba in 1976?
Provide a short and direct response. -11.67. What is the difference between the Gross enrolment ratio (%) in Low & middle income in 1975 and the Gross enrolment ratio (%) in Dominican Republic in 1976?
Your answer should be compact. 0.35. What is the difference between the Gross enrolment ratio (%) of Low & middle income in 1975 and the Gross enrolment ratio (%) of Ecuador in 1976?
Ensure brevity in your answer.  -5.44. What is the difference between the Gross enrolment ratio (%) in Cuba in 1975 and the Gross enrolment ratio (%) in Dominican Republic in 1976?
Give a very brief answer. 1.02. What is the difference between the Gross enrolment ratio (%) of Cuba in 1975 and the Gross enrolment ratio (%) of Ecuador in 1976?
Keep it short and to the point. -4.77. What is the difference between the Gross enrolment ratio (%) in Dominican Republic in 1975 and the Gross enrolment ratio (%) in Ecuador in 1976?
Offer a very short reply. -14.08. What is the difference between the Gross enrolment ratio (%) of Low & middle income in 1975 and the Gross enrolment ratio (%) of Cuba in 1977?
Your response must be concise. -20.99. What is the difference between the Gross enrolment ratio (%) in Low & middle income in 1975 and the Gross enrolment ratio (%) in Dominican Republic in 1977?
Offer a very short reply. -1.19. What is the difference between the Gross enrolment ratio (%) in Low & middle income in 1975 and the Gross enrolment ratio (%) in Ecuador in 1977?
Provide a succinct answer. -8.63. What is the difference between the Gross enrolment ratio (%) of Cuba in 1975 and the Gross enrolment ratio (%) of Dominican Republic in 1977?
Offer a terse response. -0.52. What is the difference between the Gross enrolment ratio (%) of Cuba in 1975 and the Gross enrolment ratio (%) of Ecuador in 1977?
Offer a terse response. -7.96. What is the difference between the Gross enrolment ratio (%) in Dominican Republic in 1975 and the Gross enrolment ratio (%) in Ecuador in 1977?
Give a very brief answer. -17.27. What is the difference between the Gross enrolment ratio (%) of Low & middle income in 1975 and the Gross enrolment ratio (%) of Cuba in 1978?
Your answer should be compact. -25.1. What is the difference between the Gross enrolment ratio (%) in Low & middle income in 1975 and the Gross enrolment ratio (%) in Dominican Republic in 1978?
Ensure brevity in your answer.  -2.69. What is the difference between the Gross enrolment ratio (%) in Low & middle income in 1975 and the Gross enrolment ratio (%) in Ecuador in 1978?
Make the answer very short. -10.92. What is the difference between the Gross enrolment ratio (%) of Cuba in 1975 and the Gross enrolment ratio (%) of Dominican Republic in 1978?
Your answer should be compact. -2.02. What is the difference between the Gross enrolment ratio (%) in Cuba in 1975 and the Gross enrolment ratio (%) in Ecuador in 1978?
Make the answer very short. -10.25. What is the difference between the Gross enrolment ratio (%) in Dominican Republic in 1975 and the Gross enrolment ratio (%) in Ecuador in 1978?
Give a very brief answer. -19.56. What is the difference between the Gross enrolment ratio (%) in Low & middle income in 1976 and the Gross enrolment ratio (%) in Cuba in 1977?
Your answer should be very brief. -18.8. What is the difference between the Gross enrolment ratio (%) of Low & middle income in 1976 and the Gross enrolment ratio (%) of Ecuador in 1977?
Your answer should be compact. -6.44. What is the difference between the Gross enrolment ratio (%) in Cuba in 1976 and the Gross enrolment ratio (%) in Dominican Republic in 1977?
Offer a terse response. 10.47. What is the difference between the Gross enrolment ratio (%) of Cuba in 1976 and the Gross enrolment ratio (%) of Ecuador in 1977?
Your response must be concise. 3.04. What is the difference between the Gross enrolment ratio (%) in Dominican Republic in 1976 and the Gross enrolment ratio (%) in Ecuador in 1977?
Make the answer very short. -8.98. What is the difference between the Gross enrolment ratio (%) in Low & middle income in 1976 and the Gross enrolment ratio (%) in Cuba in 1978?
Provide a succinct answer. -22.91. What is the difference between the Gross enrolment ratio (%) of Low & middle income in 1976 and the Gross enrolment ratio (%) of Dominican Republic in 1978?
Make the answer very short. -0.5. What is the difference between the Gross enrolment ratio (%) in Low & middle income in 1976 and the Gross enrolment ratio (%) in Ecuador in 1978?
Provide a short and direct response. -8.73. What is the difference between the Gross enrolment ratio (%) of Cuba in 1976 and the Gross enrolment ratio (%) of Dominican Republic in 1978?
Give a very brief answer. 8.98. What is the difference between the Gross enrolment ratio (%) in Cuba in 1976 and the Gross enrolment ratio (%) in Ecuador in 1978?
Your response must be concise. 0.74. What is the difference between the Gross enrolment ratio (%) in Dominican Republic in 1976 and the Gross enrolment ratio (%) in Ecuador in 1978?
Offer a terse response. -11.27. What is the difference between the Gross enrolment ratio (%) in Low & middle income in 1977 and the Gross enrolment ratio (%) in Cuba in 1978?
Your answer should be very brief. -21.03. What is the difference between the Gross enrolment ratio (%) in Low & middle income in 1977 and the Gross enrolment ratio (%) in Dominican Republic in 1978?
Give a very brief answer. 1.37. What is the difference between the Gross enrolment ratio (%) of Low & middle income in 1977 and the Gross enrolment ratio (%) of Ecuador in 1978?
Offer a terse response. -6.86. What is the difference between the Gross enrolment ratio (%) in Cuba in 1977 and the Gross enrolment ratio (%) in Dominican Republic in 1978?
Provide a short and direct response. 18.3. What is the difference between the Gross enrolment ratio (%) of Cuba in 1977 and the Gross enrolment ratio (%) of Ecuador in 1978?
Offer a very short reply. 10.07. What is the difference between the Gross enrolment ratio (%) in Dominican Republic in 1977 and the Gross enrolment ratio (%) in Ecuador in 1978?
Offer a very short reply. -9.73. What is the average Gross enrolment ratio (%) in Low & middle income per year?
Ensure brevity in your answer.  34.84. What is the average Gross enrolment ratio (%) of Cuba per year?
Provide a short and direct response. 36.96. What is the average Gross enrolment ratio (%) in Dominican Republic per year?
Provide a short and direct response. 27.85. What is the average Gross enrolment ratio (%) in Ecuador per year?
Keep it short and to the point. 35.23. In the year 1971, what is the difference between the Gross enrolment ratio (%) of Low & middle income and Gross enrolment ratio (%) of Cuba?
Offer a terse response. 6.14. In the year 1971, what is the difference between the Gross enrolment ratio (%) of Low & middle income and Gross enrolment ratio (%) of Dominican Republic?
Make the answer very short. 10.04. In the year 1971, what is the difference between the Gross enrolment ratio (%) in Low & middle income and Gross enrolment ratio (%) in Ecuador?
Offer a very short reply. 4.1. In the year 1971, what is the difference between the Gross enrolment ratio (%) in Cuba and Gross enrolment ratio (%) in Dominican Republic?
Give a very brief answer. 3.91. In the year 1971, what is the difference between the Gross enrolment ratio (%) in Cuba and Gross enrolment ratio (%) in Ecuador?
Offer a very short reply. -2.04. In the year 1971, what is the difference between the Gross enrolment ratio (%) in Dominican Republic and Gross enrolment ratio (%) in Ecuador?
Give a very brief answer. -5.94. In the year 1972, what is the difference between the Gross enrolment ratio (%) in Low & middle income and Gross enrolment ratio (%) in Cuba?
Make the answer very short. 10.13. In the year 1972, what is the difference between the Gross enrolment ratio (%) of Low & middle income and Gross enrolment ratio (%) of Dominican Republic?
Offer a very short reply. 10.74. In the year 1972, what is the difference between the Gross enrolment ratio (%) of Low & middle income and Gross enrolment ratio (%) of Ecuador?
Offer a terse response. 4.22. In the year 1972, what is the difference between the Gross enrolment ratio (%) of Cuba and Gross enrolment ratio (%) of Dominican Republic?
Offer a very short reply. 0.61. In the year 1972, what is the difference between the Gross enrolment ratio (%) of Cuba and Gross enrolment ratio (%) of Ecuador?
Provide a short and direct response. -5.91. In the year 1972, what is the difference between the Gross enrolment ratio (%) of Dominican Republic and Gross enrolment ratio (%) of Ecuador?
Make the answer very short. -6.52. In the year 1973, what is the difference between the Gross enrolment ratio (%) of Low & middle income and Gross enrolment ratio (%) of Cuba?
Provide a short and direct response. 9.41. In the year 1973, what is the difference between the Gross enrolment ratio (%) of Low & middle income and Gross enrolment ratio (%) of Dominican Republic?
Provide a succinct answer. 10.22. In the year 1973, what is the difference between the Gross enrolment ratio (%) in Low & middle income and Gross enrolment ratio (%) in Ecuador?
Provide a short and direct response. 3.45. In the year 1973, what is the difference between the Gross enrolment ratio (%) of Cuba and Gross enrolment ratio (%) of Dominican Republic?
Provide a succinct answer. 0.81. In the year 1973, what is the difference between the Gross enrolment ratio (%) of Cuba and Gross enrolment ratio (%) of Ecuador?
Make the answer very short. -5.96. In the year 1973, what is the difference between the Gross enrolment ratio (%) of Dominican Republic and Gross enrolment ratio (%) of Ecuador?
Provide a short and direct response. -6.77. In the year 1974, what is the difference between the Gross enrolment ratio (%) in Low & middle income and Gross enrolment ratio (%) in Cuba?
Your answer should be very brief. 5.05. In the year 1974, what is the difference between the Gross enrolment ratio (%) of Low & middle income and Gross enrolment ratio (%) of Dominican Republic?
Keep it short and to the point. 9.06. In the year 1974, what is the difference between the Gross enrolment ratio (%) in Low & middle income and Gross enrolment ratio (%) in Ecuador?
Make the answer very short. 0.85. In the year 1974, what is the difference between the Gross enrolment ratio (%) in Cuba and Gross enrolment ratio (%) in Dominican Republic?
Keep it short and to the point. 4.01. In the year 1974, what is the difference between the Gross enrolment ratio (%) of Cuba and Gross enrolment ratio (%) of Ecuador?
Offer a very short reply. -4.2. In the year 1974, what is the difference between the Gross enrolment ratio (%) of Dominican Republic and Gross enrolment ratio (%) of Ecuador?
Provide a short and direct response. -8.21. In the year 1975, what is the difference between the Gross enrolment ratio (%) in Low & middle income and Gross enrolment ratio (%) in Cuba?
Make the answer very short. -0.67. In the year 1975, what is the difference between the Gross enrolment ratio (%) of Low & middle income and Gross enrolment ratio (%) of Dominican Republic?
Offer a very short reply. 8.64. In the year 1975, what is the difference between the Gross enrolment ratio (%) in Low & middle income and Gross enrolment ratio (%) in Ecuador?
Make the answer very short. -1.54. In the year 1975, what is the difference between the Gross enrolment ratio (%) in Cuba and Gross enrolment ratio (%) in Dominican Republic?
Offer a very short reply. 9.31. In the year 1975, what is the difference between the Gross enrolment ratio (%) in Cuba and Gross enrolment ratio (%) in Ecuador?
Ensure brevity in your answer.  -0.87. In the year 1975, what is the difference between the Gross enrolment ratio (%) in Dominican Republic and Gross enrolment ratio (%) in Ecuador?
Offer a very short reply. -10.17. In the year 1976, what is the difference between the Gross enrolment ratio (%) in Low & middle income and Gross enrolment ratio (%) in Cuba?
Provide a short and direct response. -9.48. In the year 1976, what is the difference between the Gross enrolment ratio (%) of Low & middle income and Gross enrolment ratio (%) of Dominican Republic?
Your answer should be compact. 2.54. In the year 1976, what is the difference between the Gross enrolment ratio (%) in Low & middle income and Gross enrolment ratio (%) in Ecuador?
Provide a short and direct response. -3.25. In the year 1976, what is the difference between the Gross enrolment ratio (%) of Cuba and Gross enrolment ratio (%) of Dominican Republic?
Offer a terse response. 12.02. In the year 1976, what is the difference between the Gross enrolment ratio (%) in Cuba and Gross enrolment ratio (%) in Ecuador?
Keep it short and to the point. 6.23. In the year 1976, what is the difference between the Gross enrolment ratio (%) in Dominican Republic and Gross enrolment ratio (%) in Ecuador?
Offer a very short reply. -5.79. In the year 1977, what is the difference between the Gross enrolment ratio (%) in Low & middle income and Gross enrolment ratio (%) in Cuba?
Provide a short and direct response. -16.93. In the year 1977, what is the difference between the Gross enrolment ratio (%) in Low & middle income and Gross enrolment ratio (%) in Dominican Republic?
Provide a short and direct response. 2.87. In the year 1977, what is the difference between the Gross enrolment ratio (%) of Low & middle income and Gross enrolment ratio (%) of Ecuador?
Give a very brief answer. -4.57. In the year 1977, what is the difference between the Gross enrolment ratio (%) of Cuba and Gross enrolment ratio (%) of Dominican Republic?
Make the answer very short. 19.8. In the year 1977, what is the difference between the Gross enrolment ratio (%) of Cuba and Gross enrolment ratio (%) of Ecuador?
Your answer should be very brief. 12.36. In the year 1977, what is the difference between the Gross enrolment ratio (%) of Dominican Republic and Gross enrolment ratio (%) of Ecuador?
Provide a short and direct response. -7.44. In the year 1978, what is the difference between the Gross enrolment ratio (%) of Low & middle income and Gross enrolment ratio (%) of Cuba?
Provide a succinct answer. -20.55. In the year 1978, what is the difference between the Gross enrolment ratio (%) in Low & middle income and Gross enrolment ratio (%) in Dominican Republic?
Your answer should be compact. 1.86. In the year 1978, what is the difference between the Gross enrolment ratio (%) in Low & middle income and Gross enrolment ratio (%) in Ecuador?
Your answer should be very brief. -6.37. In the year 1978, what is the difference between the Gross enrolment ratio (%) in Cuba and Gross enrolment ratio (%) in Dominican Republic?
Make the answer very short. 22.4. In the year 1978, what is the difference between the Gross enrolment ratio (%) in Cuba and Gross enrolment ratio (%) in Ecuador?
Make the answer very short. 14.17. In the year 1978, what is the difference between the Gross enrolment ratio (%) of Dominican Republic and Gross enrolment ratio (%) of Ecuador?
Offer a very short reply. -8.23. What is the ratio of the Gross enrolment ratio (%) in Low & middle income in 1971 to that in 1972?
Provide a succinct answer. 0.93. What is the ratio of the Gross enrolment ratio (%) of Cuba in 1971 to that in 1972?
Give a very brief answer. 1.08. What is the ratio of the Gross enrolment ratio (%) in Dominican Republic in 1971 to that in 1972?
Your answer should be very brief. 0.93. What is the ratio of the Gross enrolment ratio (%) in Ecuador in 1971 to that in 1972?
Provide a succinct answer. 0.93. What is the ratio of the Gross enrolment ratio (%) of Low & middle income in 1971 to that in 1973?
Give a very brief answer. 0.89. What is the ratio of the Gross enrolment ratio (%) in Cuba in 1971 to that in 1973?
Make the answer very short. 0.98. What is the ratio of the Gross enrolment ratio (%) of Dominican Republic in 1971 to that in 1973?
Give a very brief answer. 0.84. What is the ratio of the Gross enrolment ratio (%) in Ecuador in 1971 to that in 1973?
Provide a short and direct response. 0.85. What is the ratio of the Gross enrolment ratio (%) of Low & middle income in 1971 to that in 1974?
Your response must be concise. 0.88. What is the ratio of the Gross enrolment ratio (%) of Cuba in 1971 to that in 1974?
Your answer should be very brief. 0.82. What is the ratio of the Gross enrolment ratio (%) of Dominican Republic in 1971 to that in 1974?
Provide a succinct answer. 0.8. What is the ratio of the Gross enrolment ratio (%) of Ecuador in 1971 to that in 1974?
Your answer should be compact. 0.78. What is the ratio of the Gross enrolment ratio (%) in Low & middle income in 1971 to that in 1975?
Make the answer very short. 0.86. What is the ratio of the Gross enrolment ratio (%) in Cuba in 1971 to that in 1975?
Offer a very short reply. 0.67. What is the ratio of the Gross enrolment ratio (%) in Dominican Republic in 1971 to that in 1975?
Your response must be concise. 0.76. What is the ratio of the Gross enrolment ratio (%) of Ecuador in 1971 to that in 1975?
Give a very brief answer. 0.71. What is the ratio of the Gross enrolment ratio (%) in Low & middle income in 1971 to that in 1976?
Your response must be concise. 0.81. What is the ratio of the Gross enrolment ratio (%) of Cuba in 1971 to that in 1976?
Offer a very short reply. 0.51. What is the ratio of the Gross enrolment ratio (%) in Dominican Republic in 1971 to that in 1976?
Provide a succinct answer. 0.58. What is the ratio of the Gross enrolment ratio (%) in Ecuador in 1971 to that in 1976?
Keep it short and to the point. 0.64. What is the ratio of the Gross enrolment ratio (%) in Low & middle income in 1971 to that in 1977?
Keep it short and to the point. 0.77. What is the ratio of the Gross enrolment ratio (%) of Cuba in 1971 to that in 1977?
Your answer should be very brief. 0.43. What is the ratio of the Gross enrolment ratio (%) in Dominican Republic in 1971 to that in 1977?
Provide a succinct answer. 0.55. What is the ratio of the Gross enrolment ratio (%) in Ecuador in 1971 to that in 1977?
Provide a short and direct response. 0.6. What is the ratio of the Gross enrolment ratio (%) in Low & middle income in 1971 to that in 1978?
Give a very brief answer. 0.76. What is the ratio of the Gross enrolment ratio (%) in Cuba in 1971 to that in 1978?
Your response must be concise. 0.4. What is the ratio of the Gross enrolment ratio (%) in Dominican Republic in 1971 to that in 1978?
Offer a very short reply. 0.53. What is the ratio of the Gross enrolment ratio (%) of Ecuador in 1971 to that in 1978?
Ensure brevity in your answer.  0.57. What is the ratio of the Gross enrolment ratio (%) in Low & middle income in 1972 to that in 1973?
Your answer should be very brief. 0.95. What is the ratio of the Gross enrolment ratio (%) in Cuba in 1972 to that in 1973?
Make the answer very short. 0.9. What is the ratio of the Gross enrolment ratio (%) in Dominican Republic in 1972 to that in 1973?
Your answer should be compact. 0.91. What is the ratio of the Gross enrolment ratio (%) of Ecuador in 1972 to that in 1973?
Your answer should be very brief. 0.92. What is the ratio of the Gross enrolment ratio (%) in Low & middle income in 1972 to that in 1974?
Your answer should be very brief. 0.95. What is the ratio of the Gross enrolment ratio (%) of Cuba in 1972 to that in 1974?
Your answer should be compact. 0.76. What is the ratio of the Gross enrolment ratio (%) in Dominican Republic in 1972 to that in 1974?
Your answer should be very brief. 0.86. What is the ratio of the Gross enrolment ratio (%) of Ecuador in 1972 to that in 1974?
Offer a very short reply. 0.84. What is the ratio of the Gross enrolment ratio (%) in Low & middle income in 1972 to that in 1975?
Your response must be concise. 0.93. What is the ratio of the Gross enrolment ratio (%) of Cuba in 1972 to that in 1975?
Your response must be concise. 0.62. What is the ratio of the Gross enrolment ratio (%) of Dominican Republic in 1972 to that in 1975?
Give a very brief answer. 0.82. What is the ratio of the Gross enrolment ratio (%) in Ecuador in 1972 to that in 1975?
Give a very brief answer. 0.77. What is the ratio of the Gross enrolment ratio (%) of Low & middle income in 1972 to that in 1976?
Make the answer very short. 0.87. What is the ratio of the Gross enrolment ratio (%) in Cuba in 1972 to that in 1976?
Ensure brevity in your answer.  0.47. What is the ratio of the Gross enrolment ratio (%) of Dominican Republic in 1972 to that in 1976?
Offer a terse response. 0.62. What is the ratio of the Gross enrolment ratio (%) in Ecuador in 1972 to that in 1976?
Make the answer very short. 0.69. What is the ratio of the Gross enrolment ratio (%) in Low & middle income in 1972 to that in 1977?
Provide a short and direct response. 0.83. What is the ratio of the Gross enrolment ratio (%) of Cuba in 1972 to that in 1977?
Offer a terse response. 0.39. What is the ratio of the Gross enrolment ratio (%) of Dominican Republic in 1972 to that in 1977?
Your answer should be very brief. 0.6. What is the ratio of the Gross enrolment ratio (%) of Ecuador in 1972 to that in 1977?
Keep it short and to the point. 0.64. What is the ratio of the Gross enrolment ratio (%) of Low & middle income in 1972 to that in 1978?
Offer a terse response. 0.82. What is the ratio of the Gross enrolment ratio (%) in Cuba in 1972 to that in 1978?
Provide a short and direct response. 0.37. What is the ratio of the Gross enrolment ratio (%) of Dominican Republic in 1972 to that in 1978?
Give a very brief answer. 0.57. What is the ratio of the Gross enrolment ratio (%) of Ecuador in 1972 to that in 1978?
Keep it short and to the point. 0.61. What is the ratio of the Gross enrolment ratio (%) of Cuba in 1973 to that in 1974?
Make the answer very short. 0.84. What is the ratio of the Gross enrolment ratio (%) in Dominican Republic in 1973 to that in 1974?
Offer a very short reply. 0.95. What is the ratio of the Gross enrolment ratio (%) of Ecuador in 1973 to that in 1974?
Provide a short and direct response. 0.92. What is the ratio of the Gross enrolment ratio (%) in Low & middle income in 1973 to that in 1975?
Your response must be concise. 0.98. What is the ratio of the Gross enrolment ratio (%) of Cuba in 1973 to that in 1975?
Offer a terse response. 0.69. What is the ratio of the Gross enrolment ratio (%) in Dominican Republic in 1973 to that in 1975?
Keep it short and to the point. 0.91. What is the ratio of the Gross enrolment ratio (%) of Ecuador in 1973 to that in 1975?
Your response must be concise. 0.84. What is the ratio of the Gross enrolment ratio (%) of Low & middle income in 1973 to that in 1976?
Give a very brief answer. 0.92. What is the ratio of the Gross enrolment ratio (%) in Cuba in 1973 to that in 1976?
Provide a short and direct response. 0.53. What is the ratio of the Gross enrolment ratio (%) in Dominican Republic in 1973 to that in 1976?
Keep it short and to the point. 0.69. What is the ratio of the Gross enrolment ratio (%) in Ecuador in 1973 to that in 1976?
Offer a very short reply. 0.76. What is the ratio of the Gross enrolment ratio (%) of Low & middle income in 1973 to that in 1977?
Provide a succinct answer. 0.87. What is the ratio of the Gross enrolment ratio (%) of Cuba in 1973 to that in 1977?
Your response must be concise. 0.44. What is the ratio of the Gross enrolment ratio (%) of Dominican Republic in 1973 to that in 1977?
Provide a succinct answer. 0.66. What is the ratio of the Gross enrolment ratio (%) of Ecuador in 1973 to that in 1977?
Your response must be concise. 0.7. What is the ratio of the Gross enrolment ratio (%) of Low & middle income in 1973 to that in 1978?
Provide a short and direct response. 0.86. What is the ratio of the Gross enrolment ratio (%) of Cuba in 1973 to that in 1978?
Give a very brief answer. 0.41. What is the ratio of the Gross enrolment ratio (%) of Dominican Republic in 1973 to that in 1978?
Provide a short and direct response. 0.63. What is the ratio of the Gross enrolment ratio (%) in Ecuador in 1973 to that in 1978?
Your answer should be compact. 0.67. What is the ratio of the Gross enrolment ratio (%) in Low & middle income in 1974 to that in 1975?
Keep it short and to the point. 0.98. What is the ratio of the Gross enrolment ratio (%) in Cuba in 1974 to that in 1975?
Keep it short and to the point. 0.82. What is the ratio of the Gross enrolment ratio (%) in Dominican Republic in 1974 to that in 1975?
Provide a succinct answer. 0.96. What is the ratio of the Gross enrolment ratio (%) of Ecuador in 1974 to that in 1975?
Ensure brevity in your answer.  0.91. What is the ratio of the Gross enrolment ratio (%) of Low & middle income in 1974 to that in 1976?
Your answer should be compact. 0.92. What is the ratio of the Gross enrolment ratio (%) of Cuba in 1974 to that in 1976?
Provide a short and direct response. 0.62. What is the ratio of the Gross enrolment ratio (%) of Dominican Republic in 1974 to that in 1976?
Your response must be concise. 0.72. What is the ratio of the Gross enrolment ratio (%) of Ecuador in 1974 to that in 1976?
Offer a terse response. 0.82. What is the ratio of the Gross enrolment ratio (%) in Low & middle income in 1974 to that in 1977?
Make the answer very short. 0.88. What is the ratio of the Gross enrolment ratio (%) of Cuba in 1974 to that in 1977?
Your answer should be compact. 0.52. What is the ratio of the Gross enrolment ratio (%) of Dominican Republic in 1974 to that in 1977?
Your answer should be compact. 0.69. What is the ratio of the Gross enrolment ratio (%) in Ecuador in 1974 to that in 1977?
Provide a short and direct response. 0.76. What is the ratio of the Gross enrolment ratio (%) in Low & middle income in 1974 to that in 1978?
Offer a terse response. 0.87. What is the ratio of the Gross enrolment ratio (%) in Cuba in 1974 to that in 1978?
Your answer should be compact. 0.48. What is the ratio of the Gross enrolment ratio (%) of Dominican Republic in 1974 to that in 1978?
Give a very brief answer. 0.67. What is the ratio of the Gross enrolment ratio (%) of Ecuador in 1974 to that in 1978?
Offer a very short reply. 0.73. What is the ratio of the Gross enrolment ratio (%) of Low & middle income in 1975 to that in 1976?
Provide a succinct answer. 0.94. What is the ratio of the Gross enrolment ratio (%) in Cuba in 1975 to that in 1976?
Provide a succinct answer. 0.76. What is the ratio of the Gross enrolment ratio (%) in Dominican Republic in 1975 to that in 1976?
Offer a terse response. 0.76. What is the ratio of the Gross enrolment ratio (%) of Ecuador in 1975 to that in 1976?
Your answer should be very brief. 0.9. What is the ratio of the Gross enrolment ratio (%) in Low & middle income in 1975 to that in 1977?
Provide a short and direct response. 0.89. What is the ratio of the Gross enrolment ratio (%) in Cuba in 1975 to that in 1977?
Your response must be concise. 0.63. What is the ratio of the Gross enrolment ratio (%) in Dominican Republic in 1975 to that in 1977?
Your answer should be compact. 0.73. What is the ratio of the Gross enrolment ratio (%) in Ecuador in 1975 to that in 1977?
Ensure brevity in your answer.  0.84. What is the ratio of the Gross enrolment ratio (%) in Low & middle income in 1975 to that in 1978?
Offer a very short reply. 0.88. What is the ratio of the Gross enrolment ratio (%) of Cuba in 1975 to that in 1978?
Give a very brief answer. 0.59. What is the ratio of the Gross enrolment ratio (%) of Dominican Republic in 1975 to that in 1978?
Your answer should be very brief. 0.7. What is the ratio of the Gross enrolment ratio (%) of Ecuador in 1975 to that in 1978?
Offer a terse response. 0.79. What is the ratio of the Gross enrolment ratio (%) of Low & middle income in 1976 to that in 1977?
Your response must be concise. 0.95. What is the ratio of the Gross enrolment ratio (%) in Cuba in 1976 to that in 1977?
Make the answer very short. 0.83. What is the ratio of the Gross enrolment ratio (%) in Dominican Republic in 1976 to that in 1977?
Your answer should be very brief. 0.96. What is the ratio of the Gross enrolment ratio (%) in Ecuador in 1976 to that in 1977?
Provide a succinct answer. 0.93. What is the ratio of the Gross enrolment ratio (%) of Low & middle income in 1976 to that in 1978?
Make the answer very short. 0.94. What is the ratio of the Gross enrolment ratio (%) in Cuba in 1976 to that in 1978?
Your response must be concise. 0.78. What is the ratio of the Gross enrolment ratio (%) of Dominican Republic in 1976 to that in 1978?
Keep it short and to the point. 0.92. What is the ratio of the Gross enrolment ratio (%) in Ecuador in 1976 to that in 1978?
Give a very brief answer. 0.88. What is the ratio of the Gross enrolment ratio (%) in Low & middle income in 1977 to that in 1978?
Offer a very short reply. 0.99. What is the ratio of the Gross enrolment ratio (%) in Cuba in 1977 to that in 1978?
Ensure brevity in your answer.  0.93. What is the ratio of the Gross enrolment ratio (%) of Dominican Republic in 1977 to that in 1978?
Keep it short and to the point. 0.96. What is the ratio of the Gross enrolment ratio (%) of Ecuador in 1977 to that in 1978?
Provide a succinct answer. 0.95. What is the difference between the highest and the second highest Gross enrolment ratio (%) of Low & middle income?
Your response must be concise. 0.49. What is the difference between the highest and the second highest Gross enrolment ratio (%) in Cuba?
Your response must be concise. 4.1. What is the difference between the highest and the second highest Gross enrolment ratio (%) of Dominican Republic?
Your response must be concise. 1.5. What is the difference between the highest and the second highest Gross enrolment ratio (%) of Ecuador?
Provide a short and direct response. 2.29. What is the difference between the highest and the lowest Gross enrolment ratio (%) of Low & middle income?
Provide a succinct answer. 9.25. What is the difference between the highest and the lowest Gross enrolment ratio (%) of Cuba?
Offer a terse response. 37.78. What is the difference between the highest and the lowest Gross enrolment ratio (%) of Dominican Republic?
Ensure brevity in your answer.  17.43. What is the difference between the highest and the lowest Gross enrolment ratio (%) in Ecuador?
Your response must be concise. 19.72. 